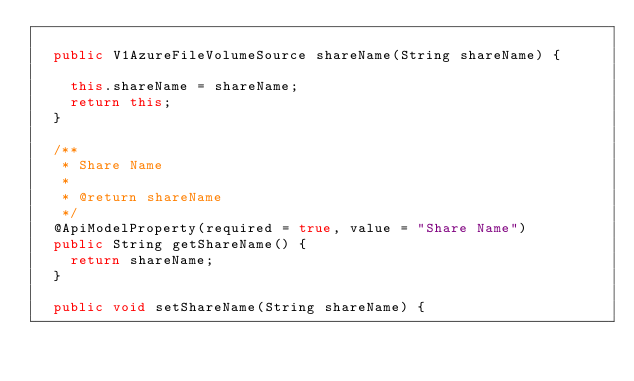Convert code to text. <code><loc_0><loc_0><loc_500><loc_500><_Java_>
  public V1AzureFileVolumeSource shareName(String shareName) {

    this.shareName = shareName;
    return this;
  }

  /**
   * Share Name
   *
   * @return shareName
   */
  @ApiModelProperty(required = true, value = "Share Name")
  public String getShareName() {
    return shareName;
  }

  public void setShareName(String shareName) {</code> 